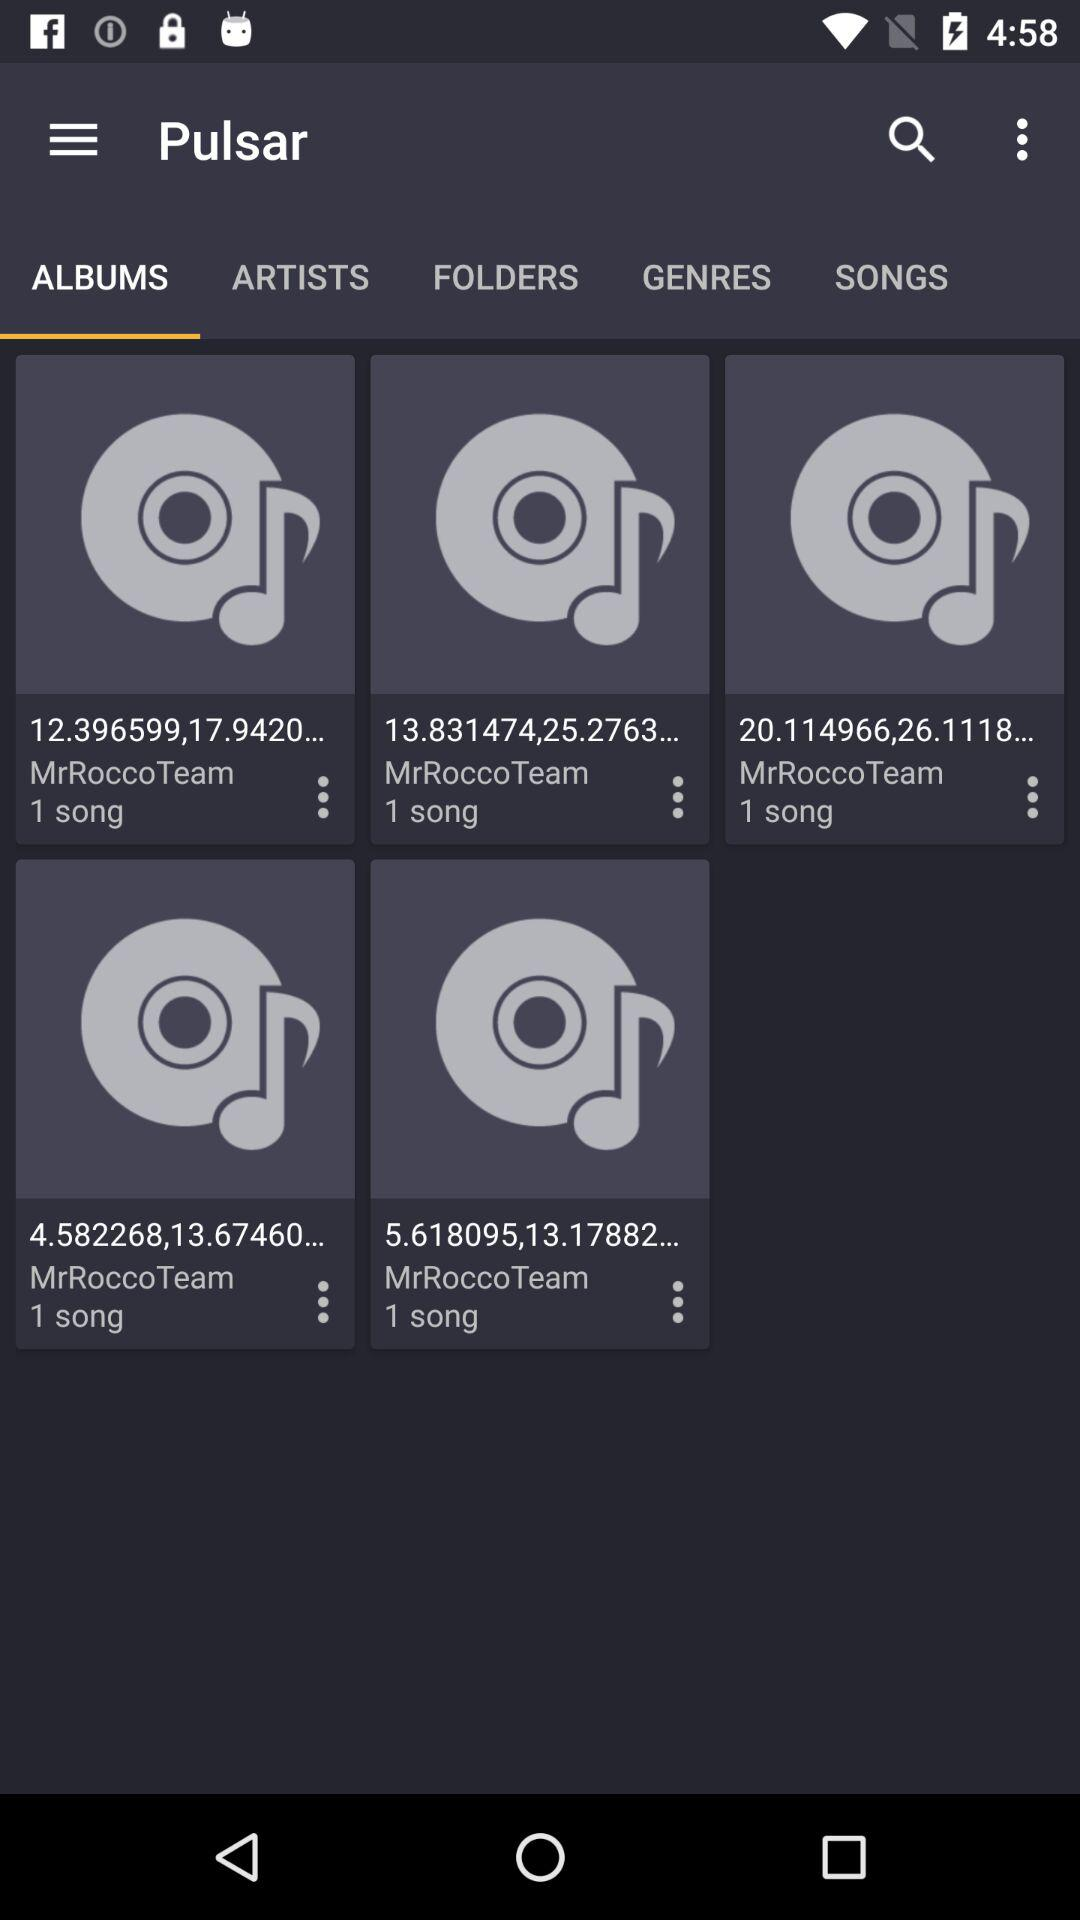Which option is selected in "Pulsar"? The selected option is "ALBUMS". 